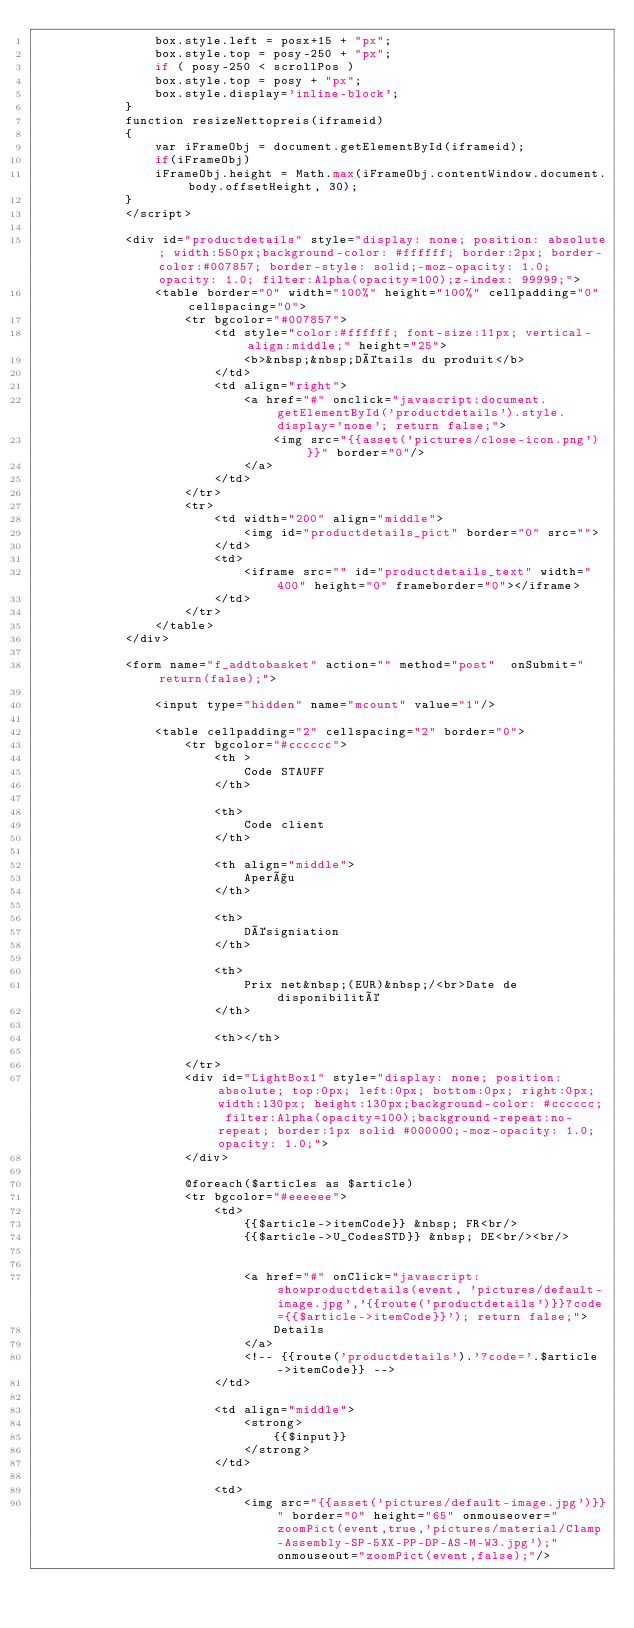<code> <loc_0><loc_0><loc_500><loc_500><_PHP_>                box.style.left = posx+15 + "px";
                box.style.top = posy-250 + "px";
                if ( posy-250 < scrollPos )
                box.style.top = posy + "px";
                box.style.display='inline-block';
            }
            function resizeNettopreis(iframeid)
            {
                var iFrameObj = document.getElementById(iframeid);
                if(iFrameObj)
                iFrameObj.height = Math.max(iFrameObj.contentWindow.document.body.offsetHeight, 30);
            }
            </script>

            <div id="productdetails" style="display: none; position: absolute; width:550px;background-color: #ffffff; border:2px; border-color:#007857; border-style: solid;-moz-opacity: 1.0; opacity: 1.0; filter:Alpha(opacity=100);z-index: 99999;">
                <table border="0" width="100%" height="100%" cellpadding="0" cellspacing="0">
                    <tr bgcolor="#007857">
                        <td style="color:#ffffff; font-size:11px; vertical-align:middle;" height="25">
                            <b>&nbsp;&nbsp;Détails du produit</b>
                        </td>
                        <td align="right">
                            <a href="#" onclick="javascript:document.getElementById('productdetails').style.display='none'; return false;">
                                <img src="{{asset('pictures/close-icon.png')}}" border="0"/>
                            </a>
                        </td>
                    </tr>
                    <tr>
                        <td width="200" align="middle">
                            <img id="productdetails_pict" border="0" src="">
                        </td>
                        <td>
                            <iframe src="" id="productdetails_text" width="400" height="0" frameborder="0"></iframe>
                        </td>
                    </tr>
                </table>
            </div>

            <form name="f_addtobasket" action="" method="post"  onSubmit="return(false);">

                <input type="hidden" name="mcount" value="1"/>

                <table cellpadding="2" cellspacing="2" border="0">
                    <tr bgcolor="#cccccc">
                        <th >
                            Code STAUFF
                        </th>

                        <th>
                            Code client
                        </th>

                        <th align="middle">
                            Aperçu
                        </th>

                        <th>
                            Désigniation
                        </th>

                        <th>
                            Prix net&nbsp;(EUR)&nbsp;/<br>Date de disponibilité
                        </th>

                        <th></th>

                    </tr>
                    <div id="LightBox1" style="display: none; position:absolute; top:0px; left:0px; bottom:0px; right:0px; width:130px; height:130px;background-color: #cccccc; filter:Alpha(opacity=100);background-repeat:no-repeat; border:1px solid #000000;-moz-opacity: 1.0; opacity: 1.0;">
                    </div>

                    @foreach($articles as $article)
                    <tr bgcolor="#eeeeee">
                        <td>
                            {{$article->itemCode}} &nbsp; FR<br/>
                            {{$article->U_CodesSTD}} &nbsp; DE<br/><br/>


                            <a href="#" onClick="javascript:showproductdetails(event, 'pictures/default-image.jpg','{{route('productdetails')}}?code={{$article->itemCode}}'); return false;">
                                Details
                            </a>
                            <!-- {{route('productdetails').'?code='.$article->itemCode}} -->
                        </td>

                        <td align="middle">
                            <strong>
                                {{$input}}
                            </strong>
                        </td>

                        <td>
                            <img src="{{asset('pictures/default-image.jpg')}}" border="0" height="65" onmouseover="zoomPict(event,true,'pictures/material/Clamp-Assembly-SP-5XX-PP-DP-AS-M-W3.jpg');" onmouseout="zoomPict(event,false);"/>
</code> 